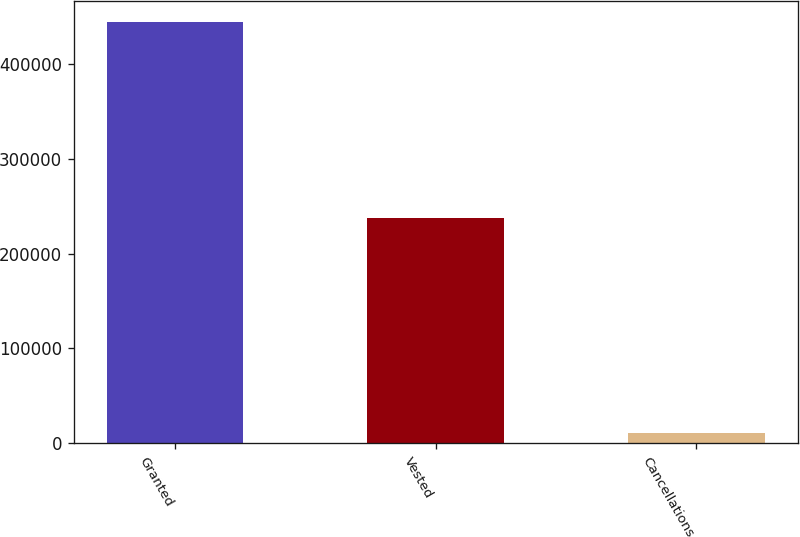<chart> <loc_0><loc_0><loc_500><loc_500><bar_chart><fcel>Granted<fcel>Vested<fcel>Cancellations<nl><fcel>444985<fcel>237370<fcel>10380<nl></chart> 